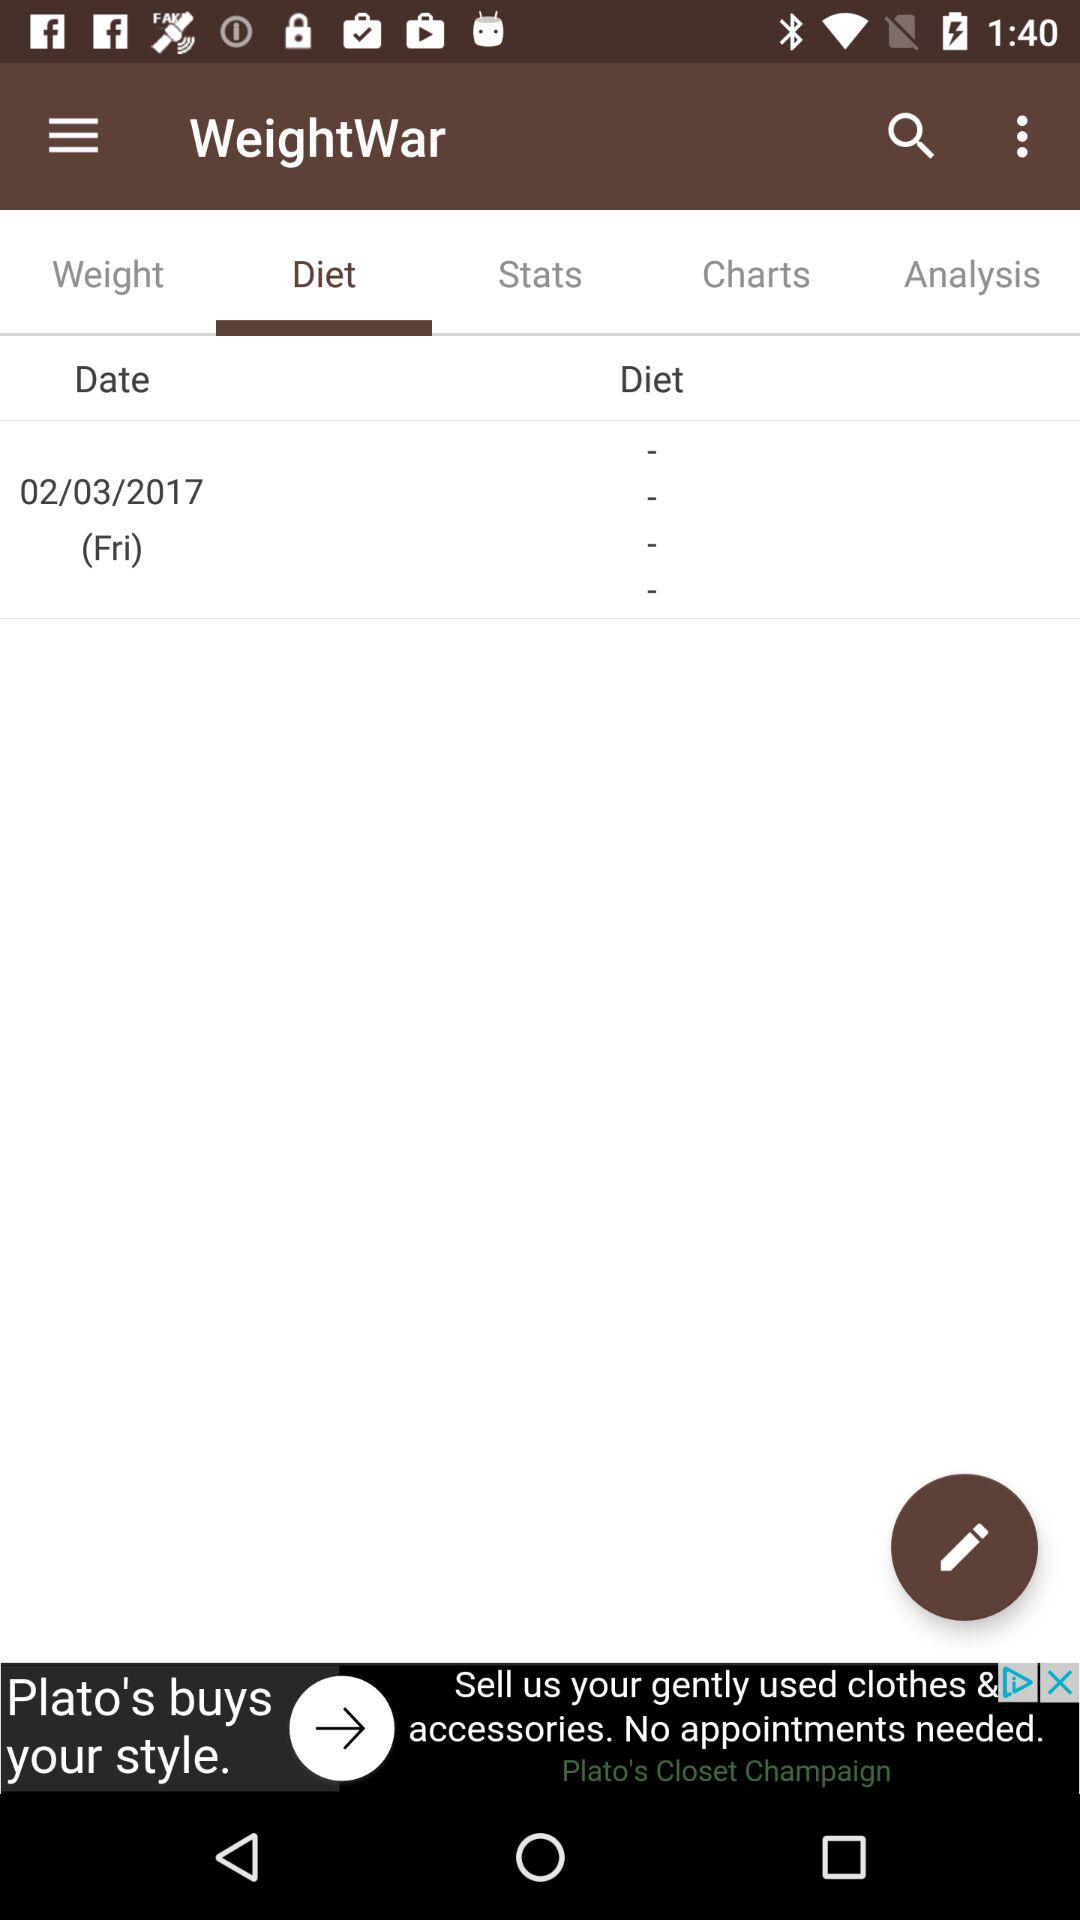What day of the diet is mentioned? The day is Friday. 